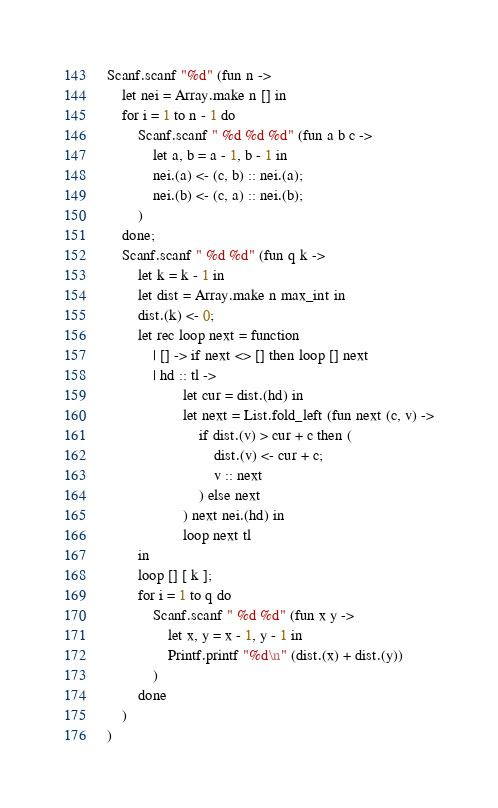<code> <loc_0><loc_0><loc_500><loc_500><_OCaml_>Scanf.scanf "%d" (fun n ->
    let nei = Array.make n [] in
    for i = 1 to n - 1 do
        Scanf.scanf " %d %d %d" (fun a b c ->
            let a, b = a - 1, b - 1 in
            nei.(a) <- (c, b) :: nei.(a);
            nei.(b) <- (c, a) :: nei.(b);
        )
    done;
    Scanf.scanf " %d %d" (fun q k ->
        let k = k - 1 in
        let dist = Array.make n max_int in
        dist.(k) <- 0;
        let rec loop next = function
            | [] -> if next <> [] then loop [] next
            | hd :: tl ->
                    let cur = dist.(hd) in
                    let next = List.fold_left (fun next (c, v) ->
                        if dist.(v) > cur + c then (
                            dist.(v) <- cur + c;
                            v :: next
                        ) else next
                    ) next nei.(hd) in
                    loop next tl
        in
        loop [] [ k ];
        for i = 1 to q do
            Scanf.scanf " %d %d" (fun x y ->
                let x, y = x - 1, y - 1 in
                Printf.printf "%d\n" (dist.(x) + dist.(y))
            )
        done
    )
)</code> 